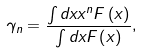<formula> <loc_0><loc_0><loc_500><loc_500>\gamma _ { n } = \frac { \int d x x ^ { n } F \left ( x \right ) } { \int d x F \left ( x \right ) } ,</formula> 